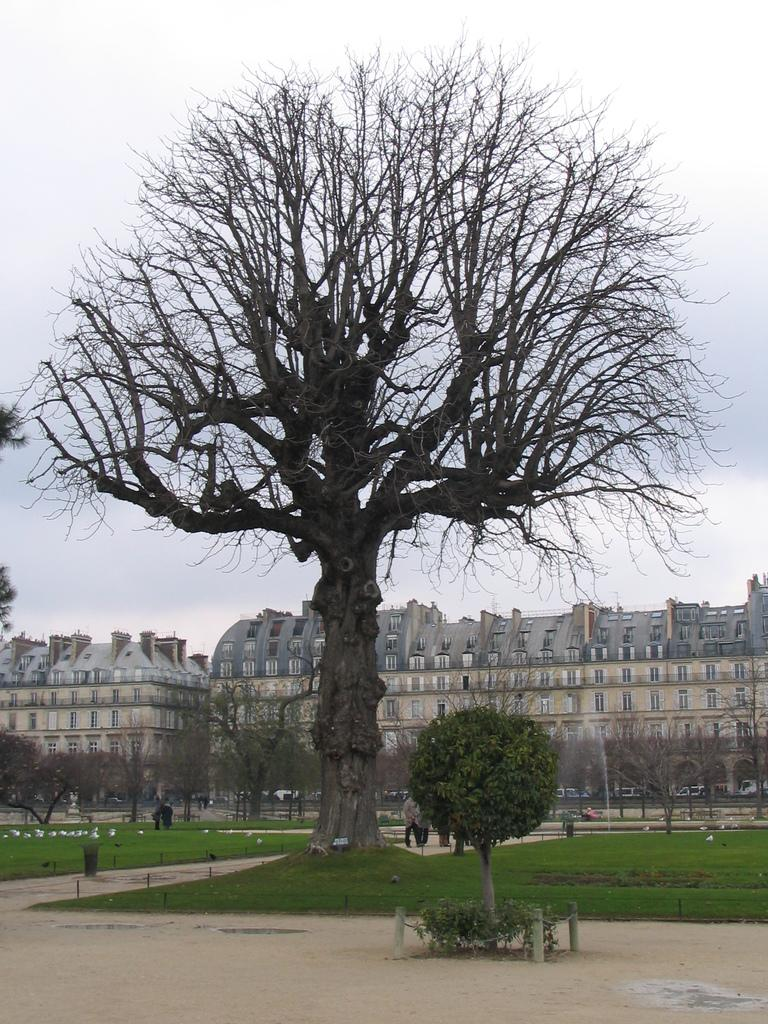What type of vegetation is present in the image? There are trees in green color in the image. What can be seen happening in the background of the image? There are persons walking in the background of the image. What is the condition of the trees in the background? There are dried trees in the background of the image. What type of structure is visible in the background of the image? There is a building in cream color in the background of the image. What is the color of the sky in the background of the image? The sky is white in color in the background of the image. What type of card is being used to measure the height of the trees in the image? There is no card present in the image, and the height of the trees is not being measured. 